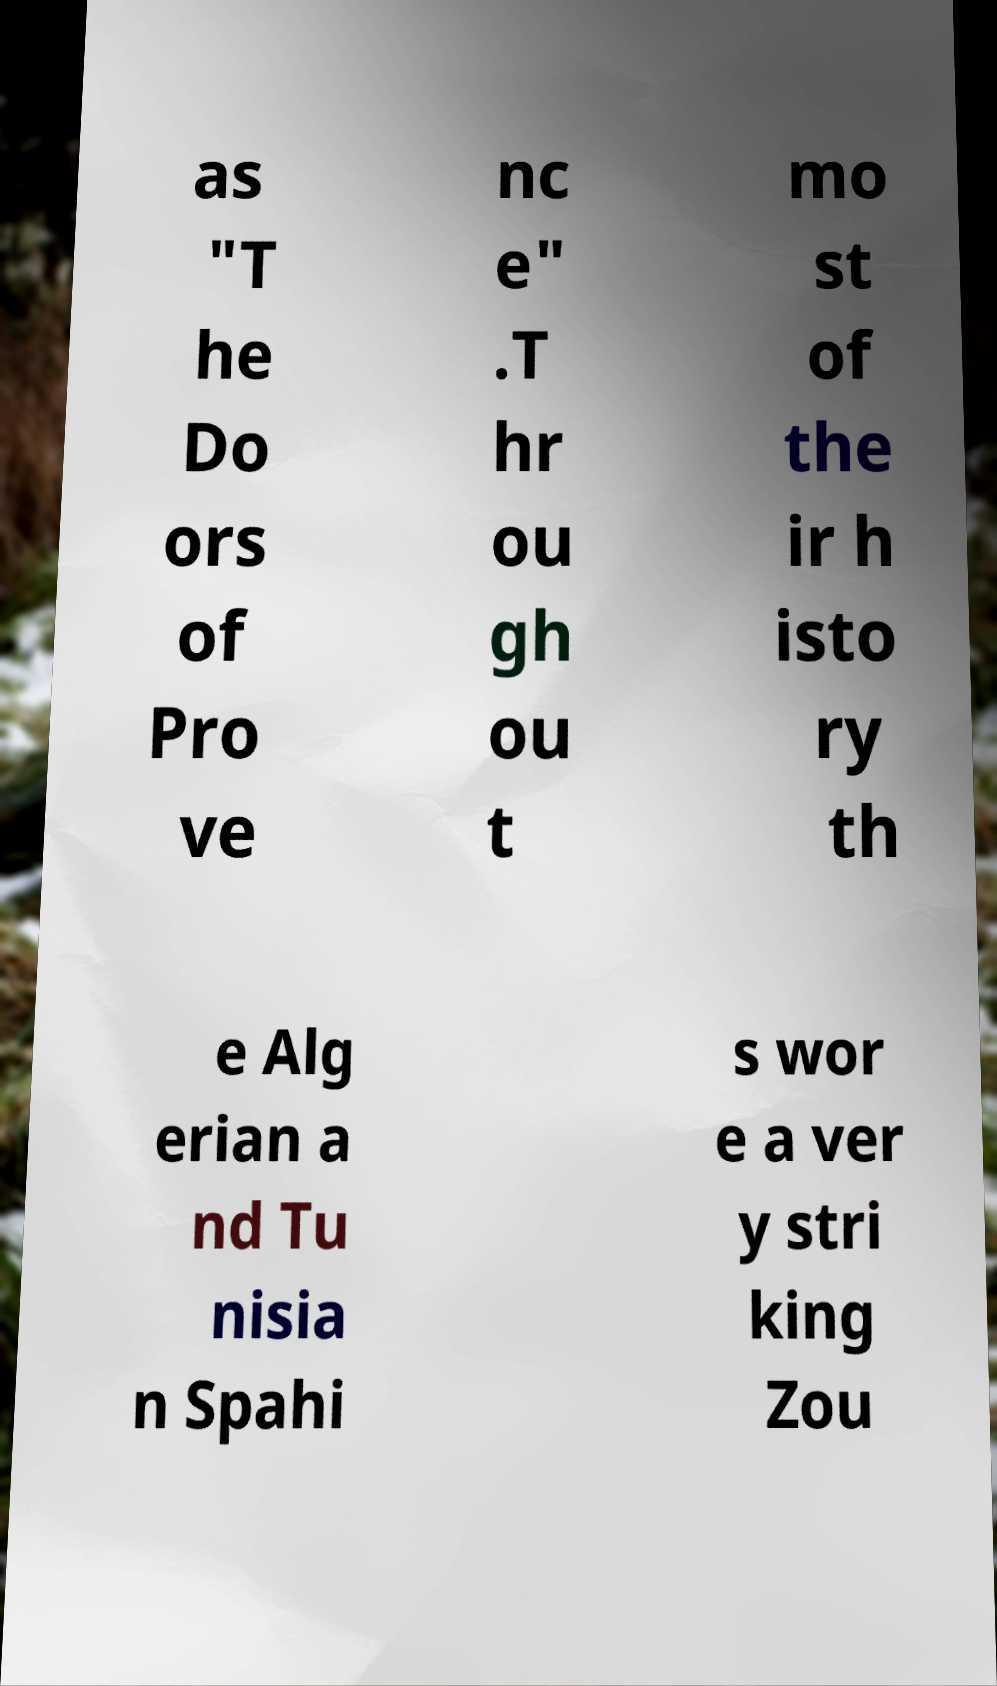Please read and relay the text visible in this image. What does it say? as "T he Do ors of Pro ve nc e" .T hr ou gh ou t mo st of the ir h isto ry th e Alg erian a nd Tu nisia n Spahi s wor e a ver y stri king Zou 